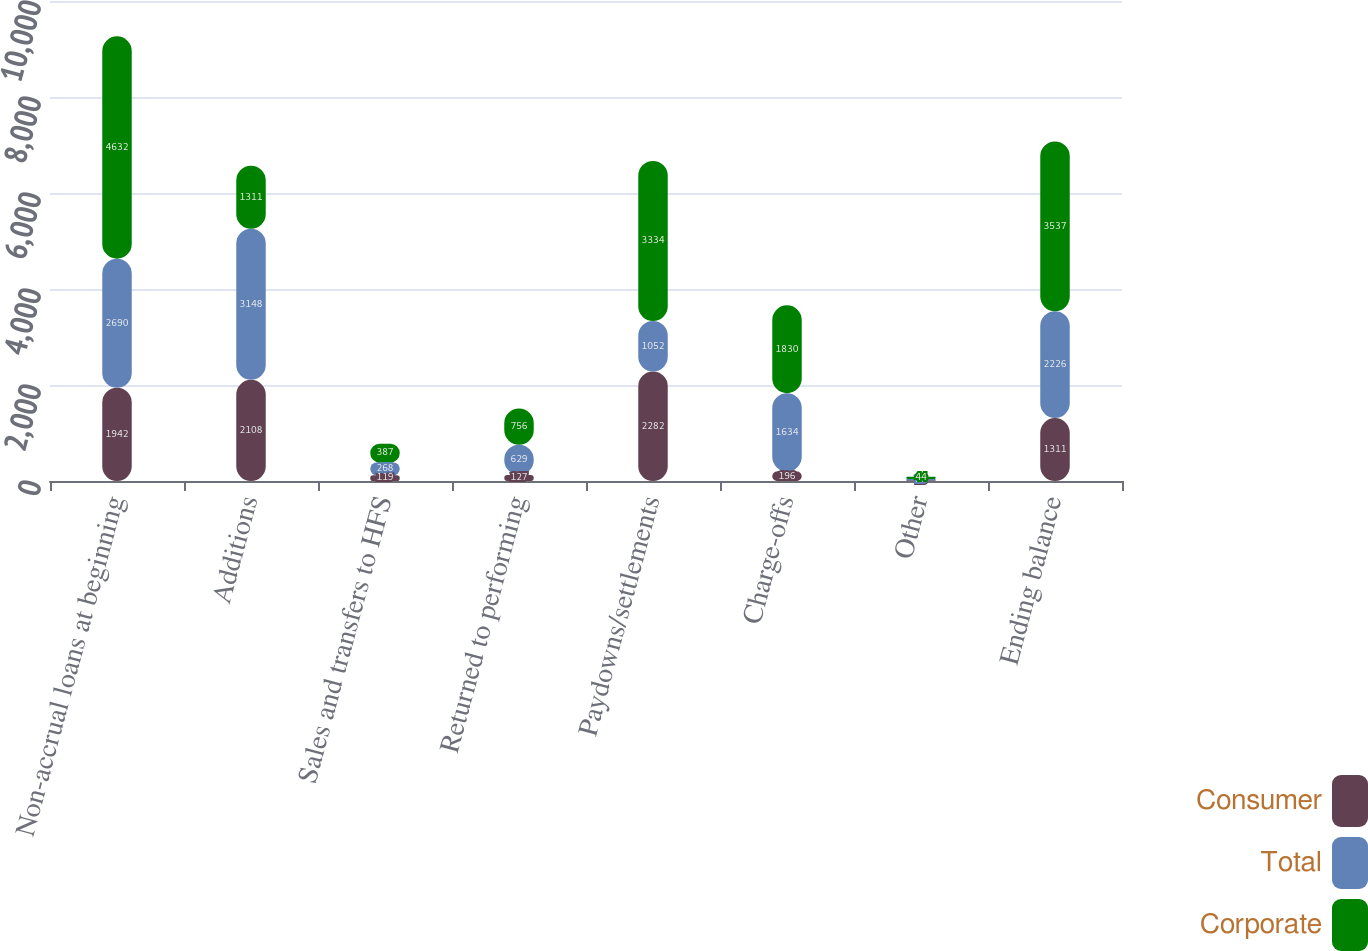Convert chart. <chart><loc_0><loc_0><loc_500><loc_500><stacked_bar_chart><ecel><fcel>Non-accrual loans at beginning<fcel>Additions<fcel>Sales and transfers to HFS<fcel>Returned to performing<fcel>Paydowns/settlements<fcel>Charge-offs<fcel>Other<fcel>Ending balance<nl><fcel>Consumer<fcel>1942<fcel>2108<fcel>119<fcel>127<fcel>2282<fcel>196<fcel>15<fcel>1311<nl><fcel>Total<fcel>2690<fcel>3148<fcel>268<fcel>629<fcel>1052<fcel>1634<fcel>29<fcel>2226<nl><fcel>Corporate<fcel>4632<fcel>1311<fcel>387<fcel>756<fcel>3334<fcel>1830<fcel>44<fcel>3537<nl></chart> 